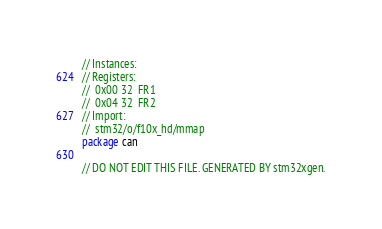Convert code to text. <code><loc_0><loc_0><loc_500><loc_500><_Go_>// Instances:
// Registers:
//  0x00 32  FR1
//  0x04 32  FR2
// Import:
//  stm32/o/f10x_hd/mmap
package can

// DO NOT EDIT THIS FILE. GENERATED BY stm32xgen.
</code> 